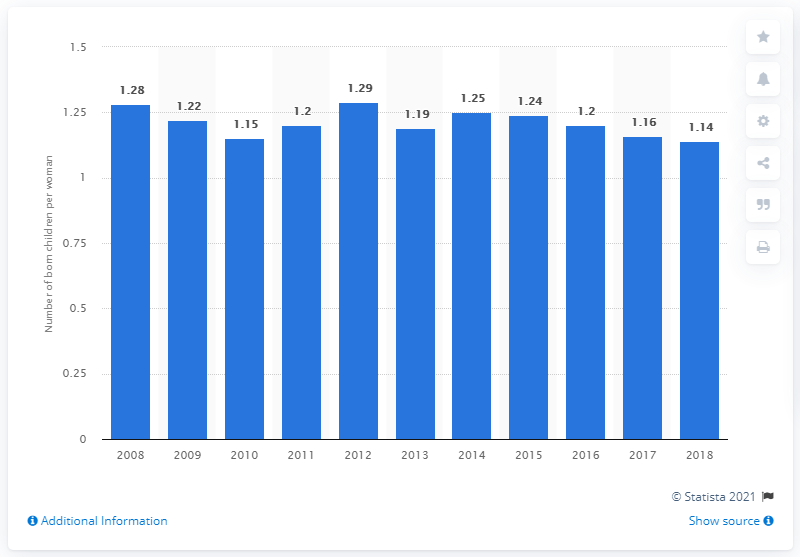Specify some key components in this picture. In 2018, the fertility rate in Singapore was 1.14. 